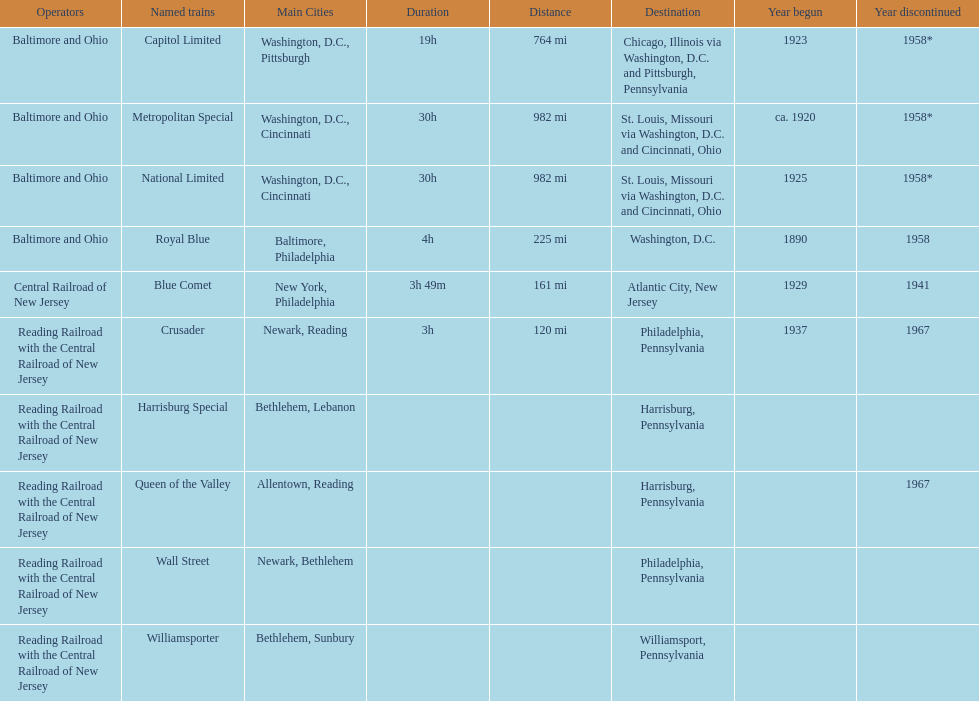What is the total of named trains? 10. 